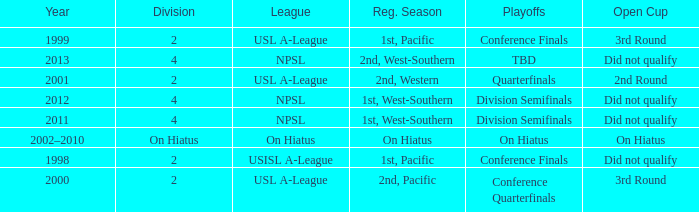Which open cup was in 2012? Did not qualify. 